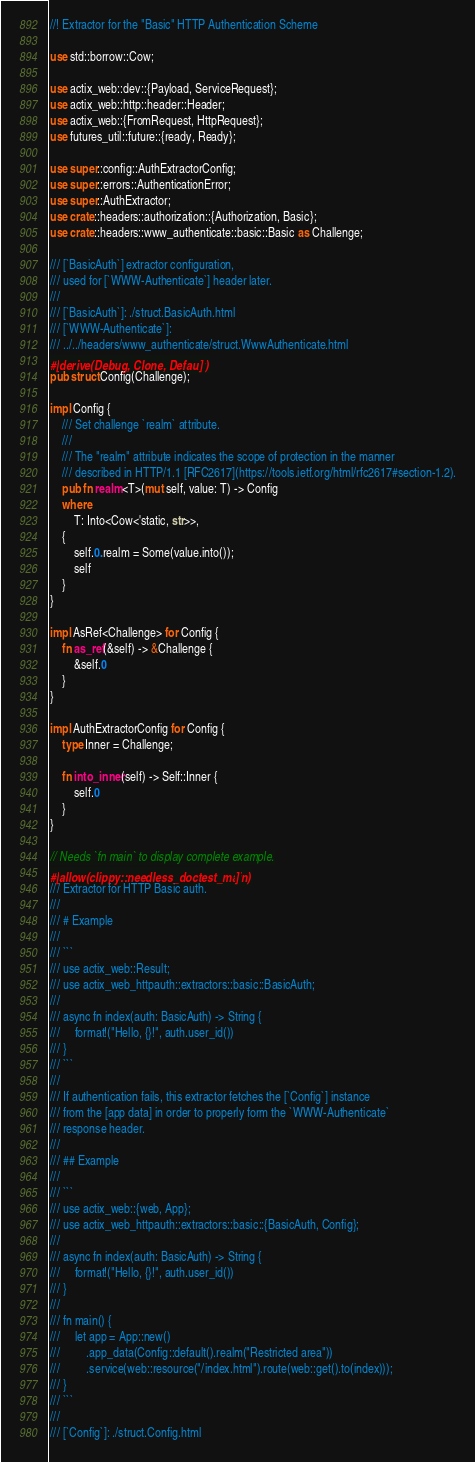Convert code to text. <code><loc_0><loc_0><loc_500><loc_500><_Rust_>//! Extractor for the "Basic" HTTP Authentication Scheme

use std::borrow::Cow;

use actix_web::dev::{Payload, ServiceRequest};
use actix_web::http::header::Header;
use actix_web::{FromRequest, HttpRequest};
use futures_util::future::{ready, Ready};

use super::config::AuthExtractorConfig;
use super::errors::AuthenticationError;
use super::AuthExtractor;
use crate::headers::authorization::{Authorization, Basic};
use crate::headers::www_authenticate::basic::Basic as Challenge;

/// [`BasicAuth`] extractor configuration,
/// used for [`WWW-Authenticate`] header later.
///
/// [`BasicAuth`]: ./struct.BasicAuth.html
/// [`WWW-Authenticate`]:
/// ../../headers/www_authenticate/struct.WwwAuthenticate.html
#[derive(Debug, Clone, Default)]
pub struct Config(Challenge);

impl Config {
    /// Set challenge `realm` attribute.
    ///
    /// The "realm" attribute indicates the scope of protection in the manner
    /// described in HTTP/1.1 [RFC2617](https://tools.ietf.org/html/rfc2617#section-1.2).
    pub fn realm<T>(mut self, value: T) -> Config
    where
        T: Into<Cow<'static, str>>,
    {
        self.0.realm = Some(value.into());
        self
    }
}

impl AsRef<Challenge> for Config {
    fn as_ref(&self) -> &Challenge {
        &self.0
    }
}

impl AuthExtractorConfig for Config {
    type Inner = Challenge;

    fn into_inner(self) -> Self::Inner {
        self.0
    }
}

// Needs `fn main` to display complete example.
#[allow(clippy::needless_doctest_main)]
/// Extractor for HTTP Basic auth.
///
/// # Example
///
/// ```
/// use actix_web::Result;
/// use actix_web_httpauth::extractors::basic::BasicAuth;
///
/// async fn index(auth: BasicAuth) -> String {
///     format!("Hello, {}!", auth.user_id())
/// }
/// ```
///
/// If authentication fails, this extractor fetches the [`Config`] instance
/// from the [app data] in order to properly form the `WWW-Authenticate`
/// response header.
///
/// ## Example
///
/// ```
/// use actix_web::{web, App};
/// use actix_web_httpauth::extractors::basic::{BasicAuth, Config};
///
/// async fn index(auth: BasicAuth) -> String {
///     format!("Hello, {}!", auth.user_id())
/// }
///
/// fn main() {
///     let app = App::new()
///         .app_data(Config::default().realm("Restricted area"))
///         .service(web::resource("/index.html").route(web::get().to(index)));
/// }
/// ```
///
/// [`Config`]: ./struct.Config.html</code> 